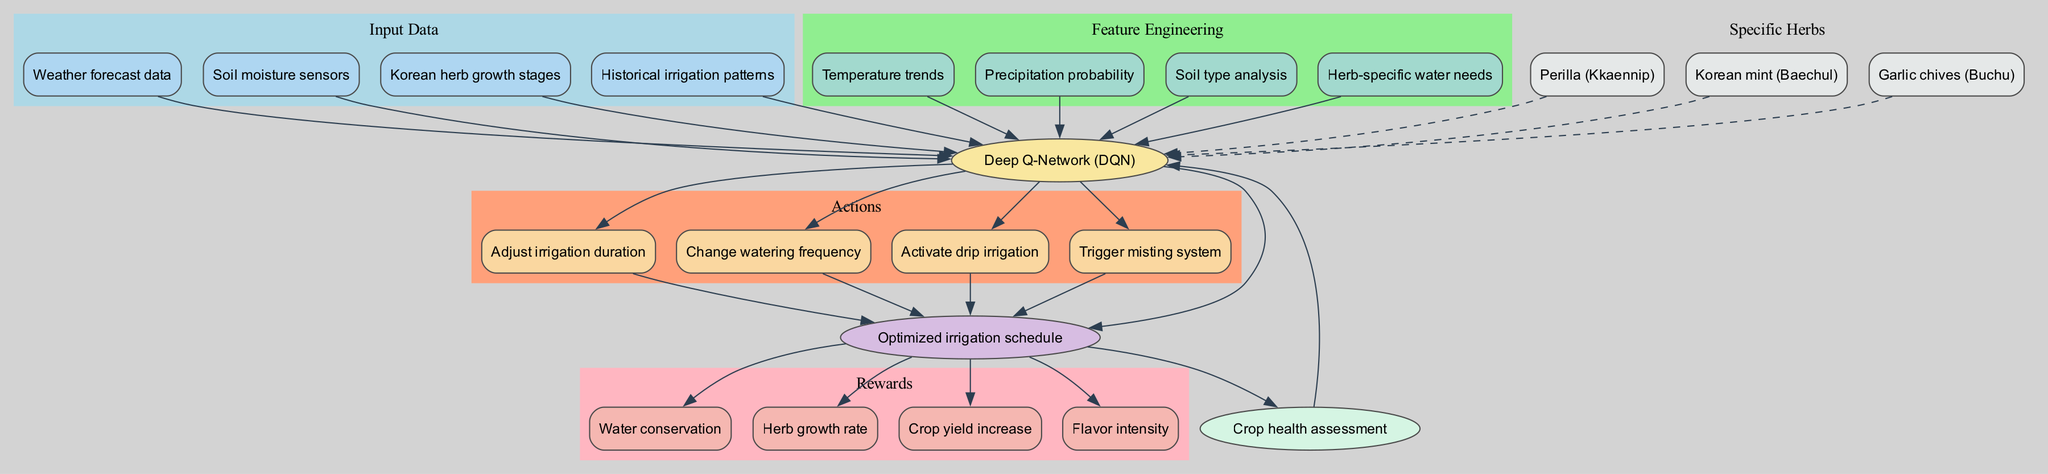What is the model used in this irrigation optimization diagram? The diagram specifies the model being used as a "Deep Q-Network (DQN)." This information is typically found in the central part of machine learning diagrams, where the model type is indicated.
Answer: Deep Q-Network (DQN) How many actions are defined in this model? The diagram lists four actions: "Adjust irrigation duration," "Change watering frequency," "Activate drip irrigation," and "Trigger misting system." Hence, by counting these actions, we find that there are four of them.
Answer: 4 What is the feedback loop in this model? The diagram indicates that the feedback loop is labeled "Crop health assessment." This is typically shown as a process that connects back to the model to improve its decision-making based on previous outcomes.
Answer: Crop health assessment Which herb is associated with the highest potential flavor intensity reward? In the rewards section of the diagram, "Flavor intensity" is one of the specific rewards. It doesn’t specify which herb it is associated with since all herbs can correlate with flavor intensity improvements based on irrigation. However, this is a general feature applicable to all specific herbs listed, as no specific herb is mentioned directly in this context.
Answer: Not specific (applicable to all herbs) What type of data is used as input in the model? The input data section lists four items: "Weather forecast data," "Soil moisture sensors," "Korean herb growth stages," and "Historical irrigation patterns." Input data typically provides the necessary context for the model's learning process.
Answer: Weather forecast data, Soil moisture sensors, Korean herb growth stages, Historical irrigation patterns How does the model receive feedback? The diagram shows a feedback arrow connecting the output to "Crop health assessment" and back to the model. This indicates that the model's decisions are evaluated based on crop health metrics, which then inform future model adjustments.
Answer: Through "Crop health assessment" Which specific herbs are targeted by the irrigation optimization model? The diagram identifies three specific herbs: "Perilla (Kkaennip)," "Korean mint (Baechul)," and "Garlic chives (Buchu)." These herbs are highlighted within their own section, distinguishing them from other elements of the diagram.
Answer: Perilla (Kkaennip), Korean mint (Baechul), Garlic chives (Buchu) What are the rewards that the model aims to optimize? The rewards include "Water conservation," "Herb growth rate," "Crop yield increase," and "Flavor intensity." Each reward is typically aimed at representing the benefits the model seeks to maximize from the actions it takes regarding irrigation.
Answer: Water conservation, Herb growth rate, Crop yield increase, Flavor intensity What relationship exists between the model and the output? The diagram indicates a direct edge from the model to the output labeled "Optimized irrigation schedule." This signifies that the model generates an output based on the processed inputs and features.
Answer: Direct connection (from model to output) 